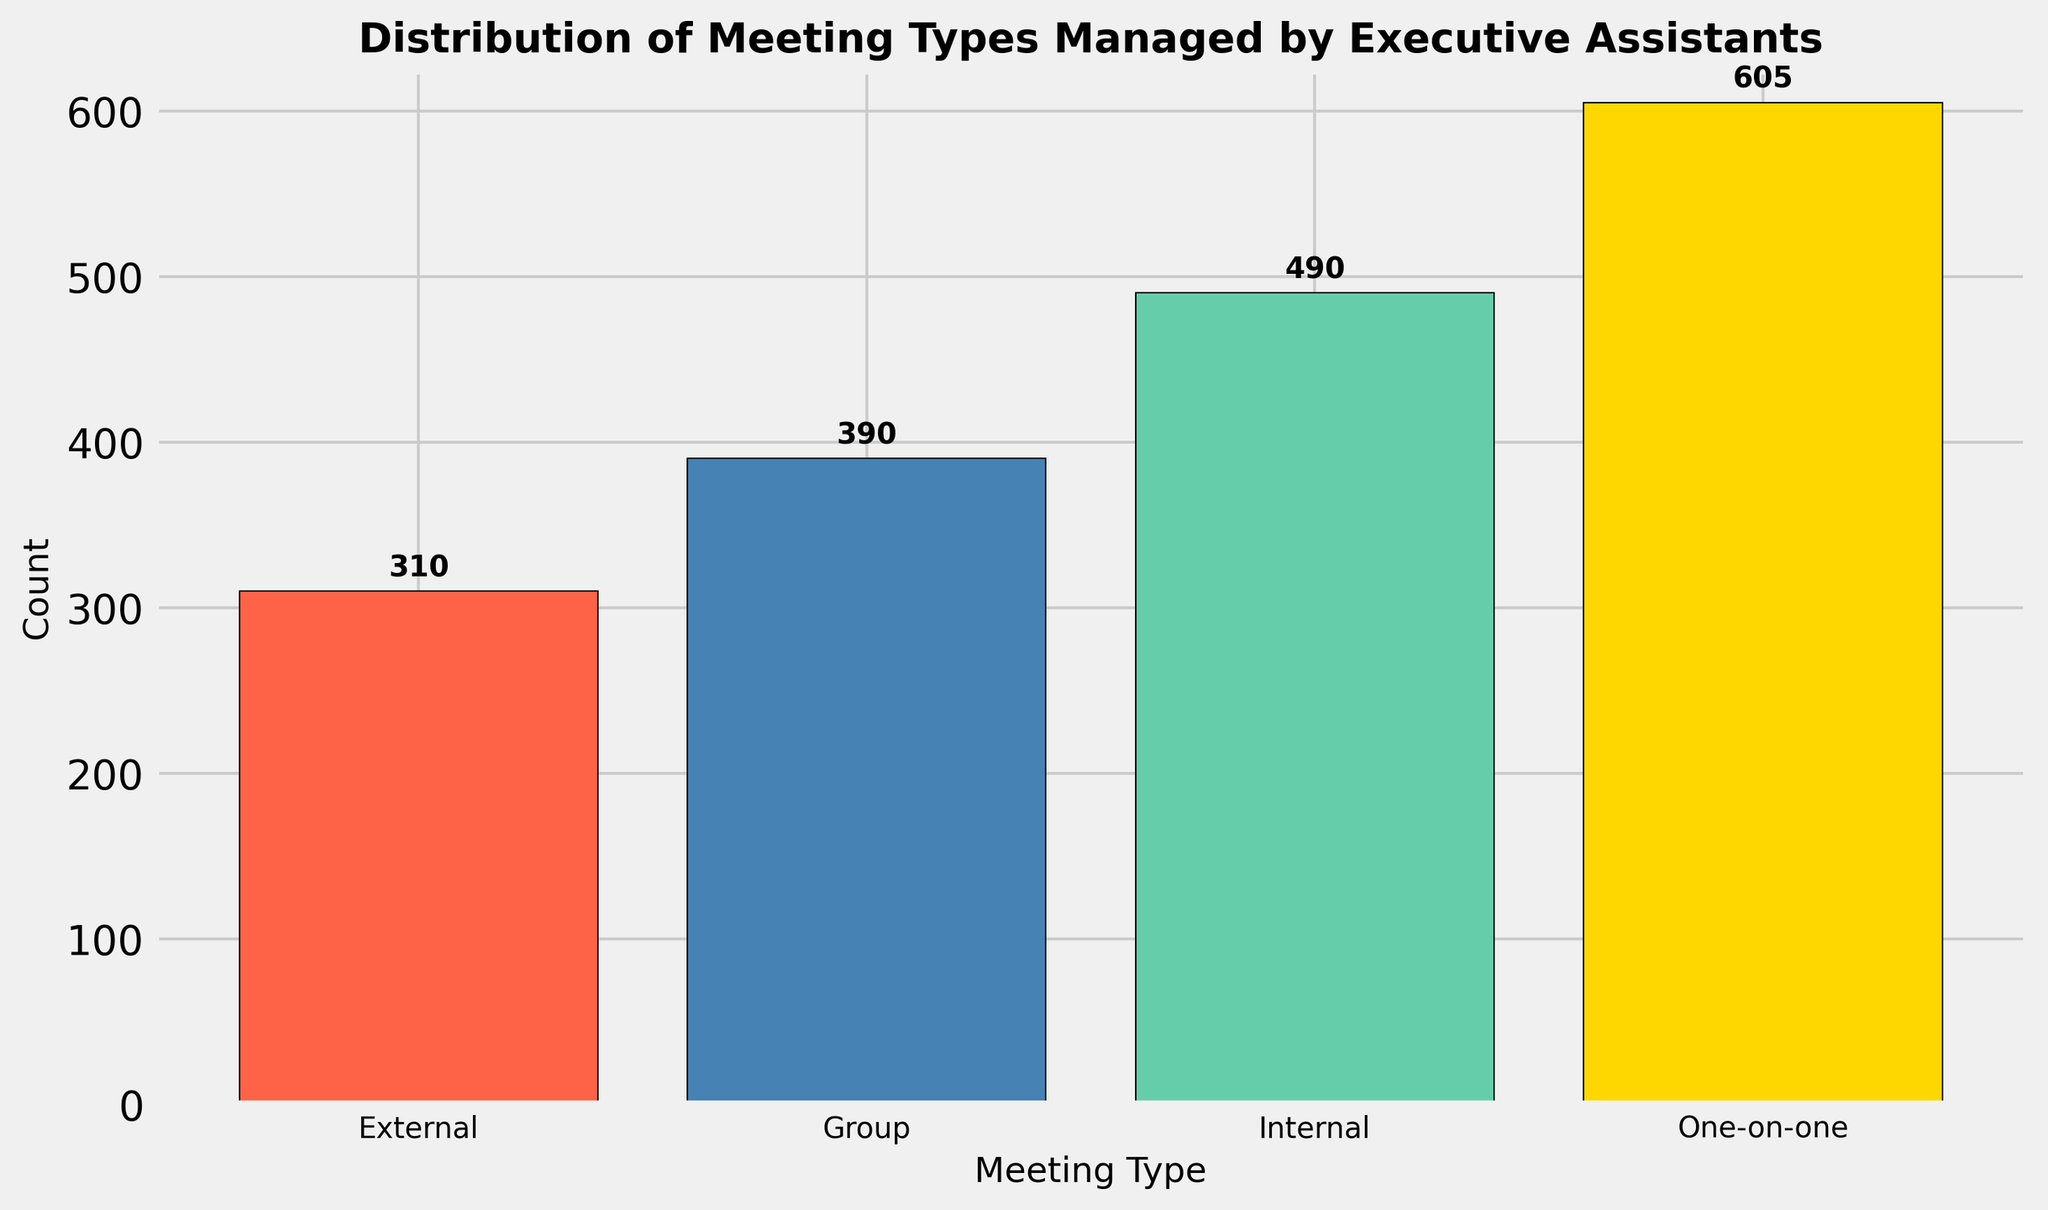What is the total count of all meeting types managed by executive assistants? To find the total count, we need to sum the counts of all the meeting types. The counts are 490 for Internal, 310 for External, 605 for One-on-one, and 390 for Group. So, the total count is 490 + 310 + 605 + 390 = 1795.
Answer: 1795 Which meeting type has the highest count? By comparing the heights of the bars, we see that One-on-one has the tallest bar, indicating it has the highest count.
Answer: One-on-one How many more One-on-one meetings are there compared to External meetings? First, find the count of One-on-one meetings (605) and the count of External meetings (310). The difference is 605 - 310 = 295.
Answer: 295 What is the average count per meeting type? To find the average, sum all counts (1795) and divide by the number of unique meeting types (4). The average is 1795 / 4 = 448.75.
Answer: 448.75 Which meeting type has the lowest count? By observing the shortest bar, we can see that the External meeting type has the lowest count at 310.
Answer: External What is the difference in count between the Internal and Group meeting types? The count for Internal meetings is 490 and for Group meetings, it is 390. The difference is 490 - 390 = 100.
Answer: 100 What is the combined count of Internal and Group meetings? The count for Internal meetings is 490, and for Group meetings, it is 390. The combined count is 490 + 390 = 880.
Answer: 880 What fraction of the total meetings is made up of External meetings? First, determine the total count of meetings, which is 1795. The count of External meetings is 310. The fraction is 310 / 1795. To simplify, 310 / 1795 ≈ 0.173.
Answer: 0.173 How tall is the bar representing Group meetings relative to the bar representing Internal meetings? The height of the bar for Group meetings is 390, and the height of the bar for Internal meetings is 490. To compare, (390 / 490) ≈ 0.796, indicating that the Group bar is about 79.6% the height of the Internal bar.
Answer: 79.6% What percentage of the One-on-one meetings are there in the total meetings? First, find the percentage by dividing the count of One-on-one meetings (605) by the total count (1795) and then multiply by 100 to get the percentage. (605 / 1795) * 100 ≈ 33.7%.
Answer: 33.7% 